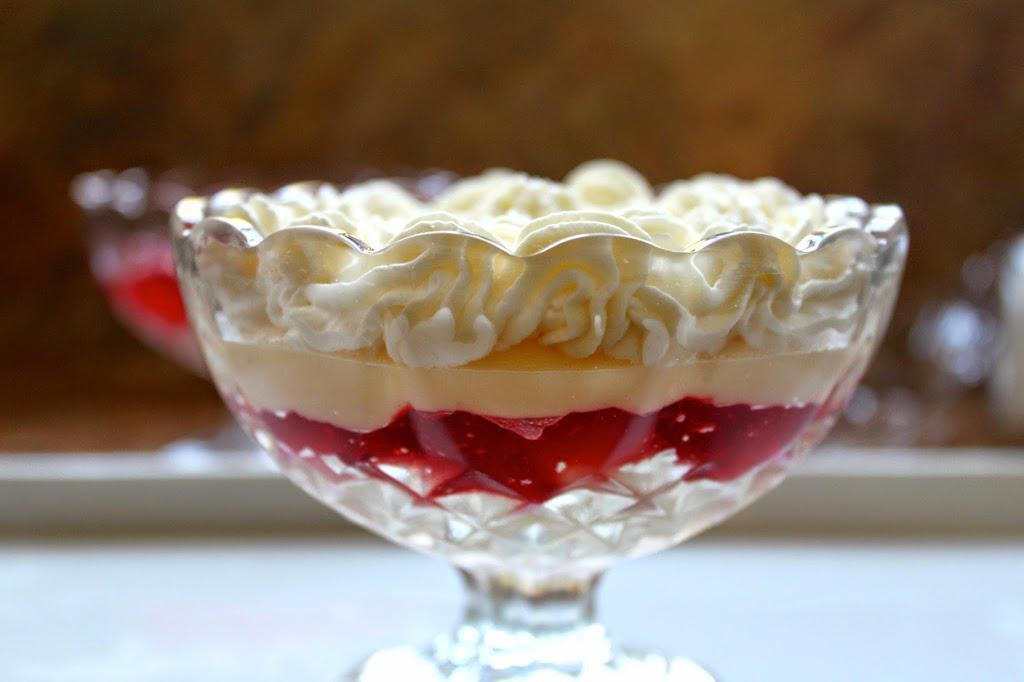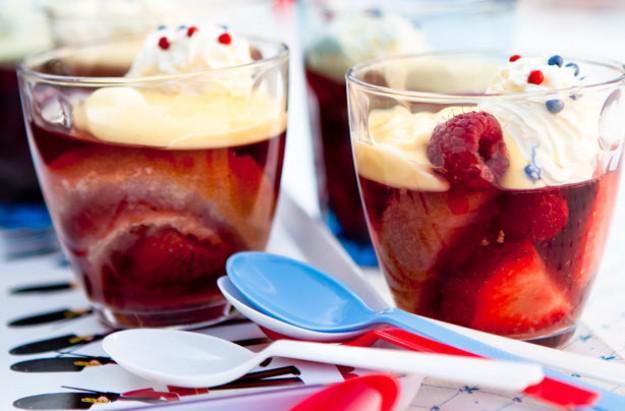The first image is the image on the left, the second image is the image on the right. Assess this claim about the two images: "One of the images shows exactly one dessert container.". Correct or not? Answer yes or no. Yes. The first image is the image on the left, the second image is the image on the right. Examine the images to the left and right. Is the description "The left photo contains two cups full of dessert." accurate? Answer yes or no. No. 